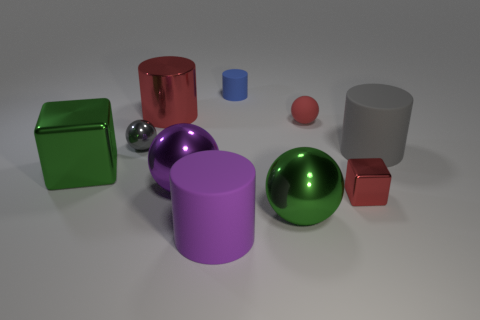What shape is the shiny object that is the same color as the tiny block?
Ensure brevity in your answer.  Cylinder. There is a big object that is behind the matte sphere; is it the same color as the cube in front of the big green block?
Your response must be concise. Yes. How many gray spheres are the same size as the blue rubber cylinder?
Make the answer very short. 1. Is the size of the rubber object behind the big red shiny cylinder the same as the sphere that is on the left side of the big red thing?
Keep it short and to the point. Yes. The green shiny thing on the left side of the large shiny cylinder has what shape?
Give a very brief answer. Cube. There is a block that is to the right of the big green metallic object to the right of the large red metal cylinder; what is it made of?
Provide a short and direct response. Metal. Are there any shiny blocks of the same color as the metal cylinder?
Provide a succinct answer. Yes. There is a purple rubber cylinder; does it have the same size as the red shiny block that is behind the large purple cylinder?
Ensure brevity in your answer.  No. There is a small shiny thing to the left of the large green sphere that is to the right of the green metal block; what number of gray things are in front of it?
Provide a succinct answer. 1. What number of green metal cubes are to the right of the blue object?
Your answer should be very brief. 0. 